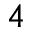Convert formula to latex. <formula><loc_0><loc_0><loc_500><loc_500>4</formula> 